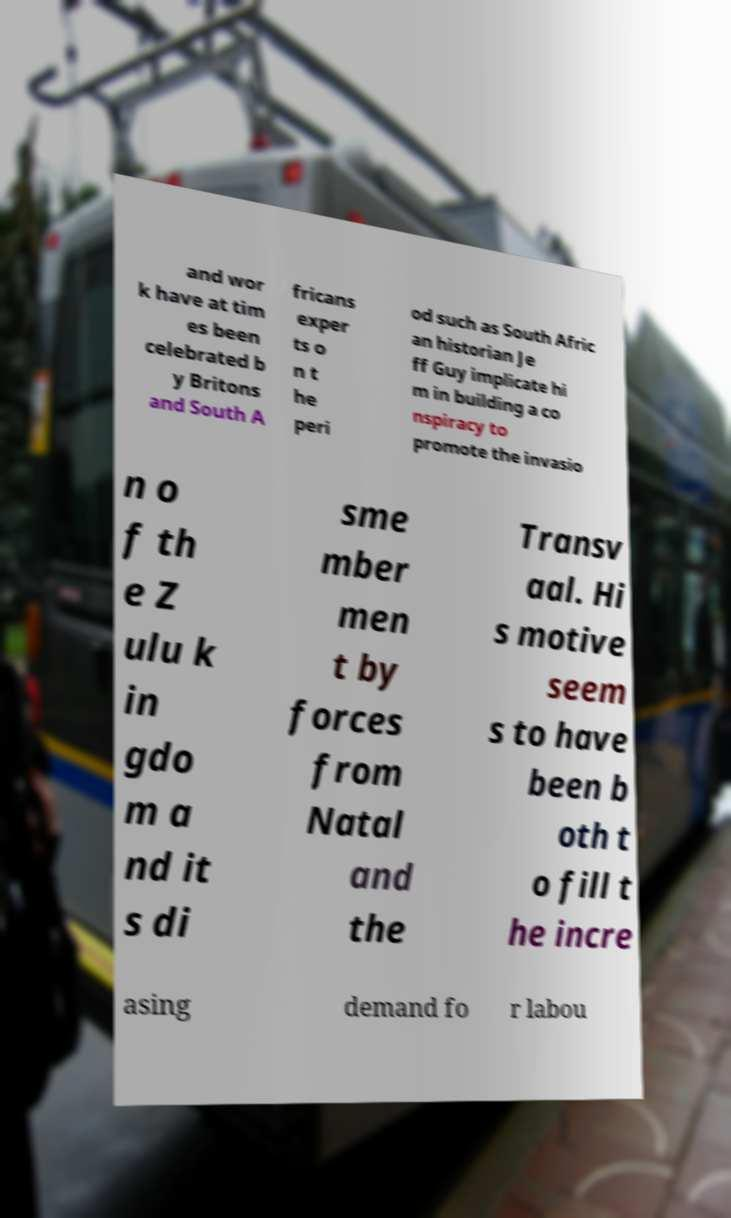There's text embedded in this image that I need extracted. Can you transcribe it verbatim? and wor k have at tim es been celebrated b y Britons and South A fricans exper ts o n t he peri od such as South Afric an historian Je ff Guy implicate hi m in building a co nspiracy to promote the invasio n o f th e Z ulu k in gdo m a nd it s di sme mber men t by forces from Natal and the Transv aal. Hi s motive seem s to have been b oth t o fill t he incre asing demand fo r labou 